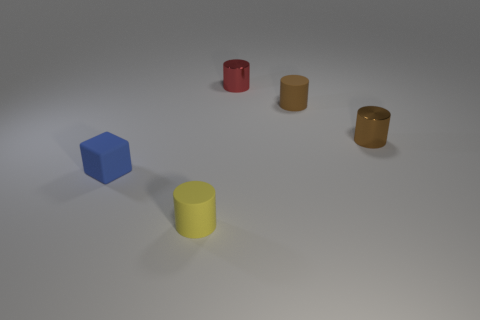Subtract all yellow rubber cylinders. How many cylinders are left? 3 Subtract all red blocks. How many brown cylinders are left? 2 Subtract all yellow cylinders. How many cylinders are left? 3 Add 1 tiny things. How many objects exist? 6 Subtract all cyan cylinders. Subtract all green spheres. How many cylinders are left? 4 Subtract all cylinders. How many objects are left? 1 Subtract 0 yellow blocks. How many objects are left? 5 Subtract all blocks. Subtract all tiny blue things. How many objects are left? 3 Add 2 tiny red shiny cylinders. How many tiny red shiny cylinders are left? 3 Add 4 small gray rubber spheres. How many small gray rubber spheres exist? 4 